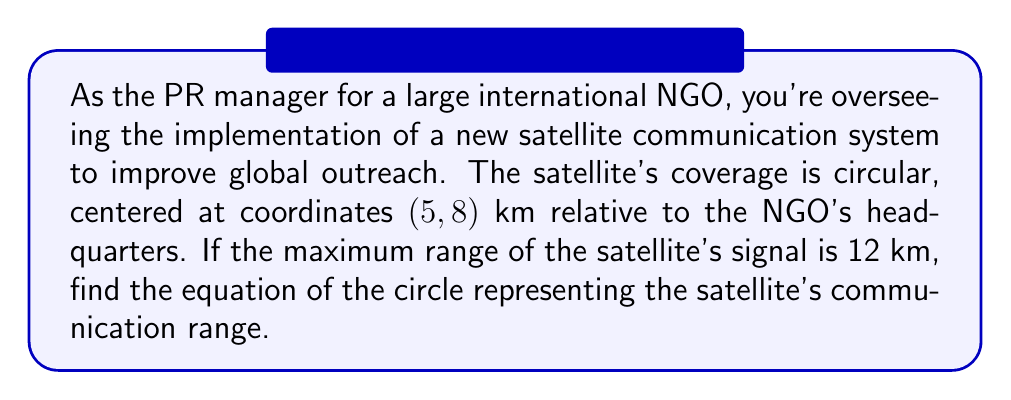What is the answer to this math problem? To find the equation of a circle, we need to use the general form:

$$(x - h)^2 + (y - k)^2 = r^2$$

Where $(h, k)$ is the center of the circle, and $r$ is the radius.

Given information:
- Center: (5, 8) km
- Radius: 12 km

Let's plug these values into the equation:

1. Center coordinates:
   $h = 5$
   $k = 8$

2. Radius:
   $r = 12$

3. Substituting into the general form:

   $$(x - 5)^2 + (y - 8)^2 = 12^2$$

4. Simplify the right side:

   $$(x - 5)^2 + (y - 8)^2 = 144$$

This is the equation of the circle representing the satellite's communication range.

[asy]
import geometry;

size(200);
dot((5,8),red);
draw(circle((5,8),12),blue);
draw((-7,-4)--(17,20),gray);
draw((-7,8)--(17,8),gray);
draw((5,-4)--(5,20),gray);
label("(5,8)",(5,8),NE);
label("12 km",((5,8)+(12,0)/sqrt(2)),NE);
</asy]
Answer: $$(x - 5)^2 + (y - 8)^2 = 144$$ 